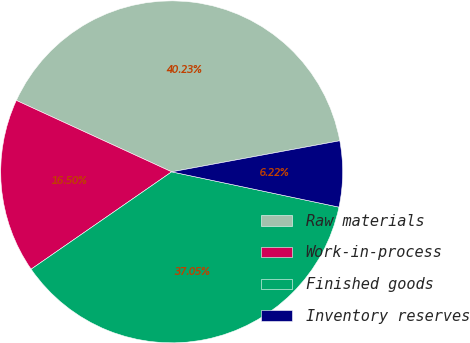Convert chart. <chart><loc_0><loc_0><loc_500><loc_500><pie_chart><fcel>Raw materials<fcel>Work-in-process<fcel>Finished goods<fcel>Inventory reserves<nl><fcel>40.23%<fcel>16.5%<fcel>37.05%<fcel>6.22%<nl></chart> 